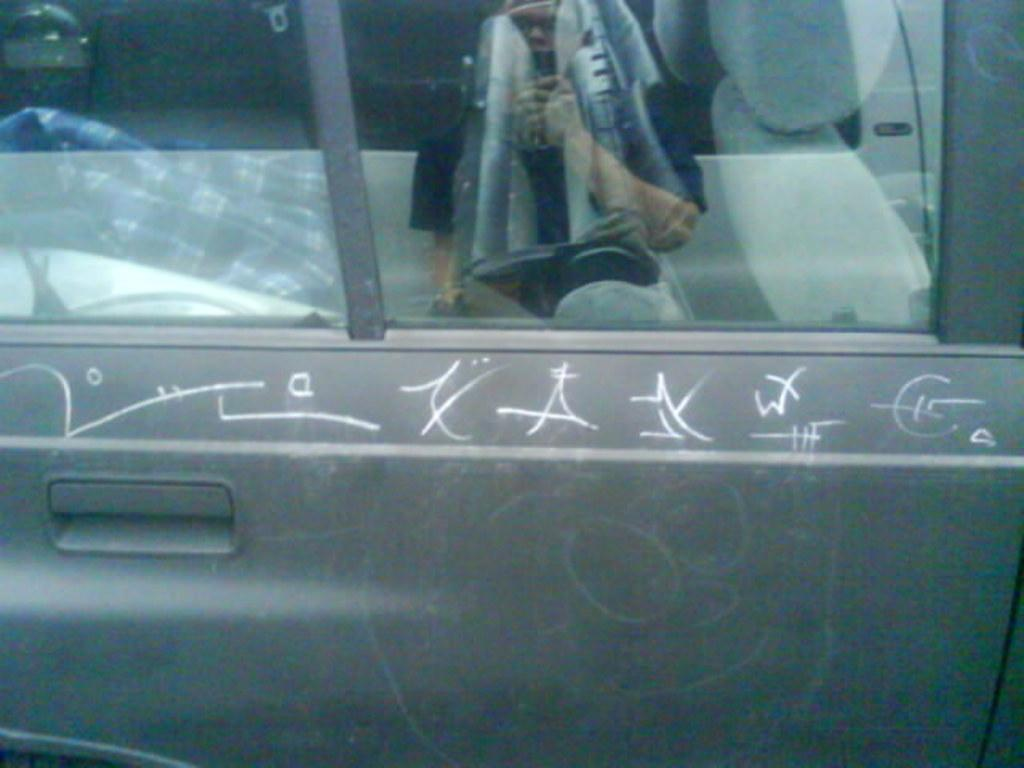What part of a vehicle is shown in the image? There is a car door with glass windows in the image. Is there any text or design on the car door? Yes, there is writing on the car door. What can be seen in the glass windows of the car door? There is a reflection of a person on the glass windows. What type of music can be heard coming from the carriage in the image? There is no carriage present in the image, so it's not possible to determine what, if any, music might be heard. 